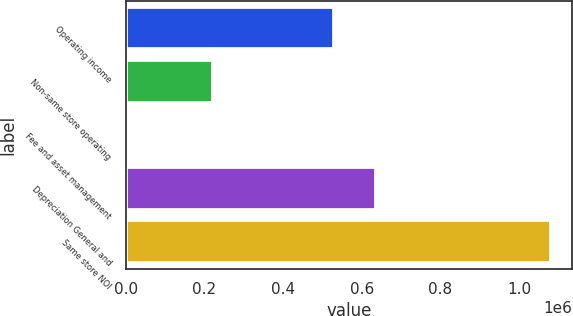<chart> <loc_0><loc_0><loc_500><loc_500><bar_chart><fcel>Operating income<fcel>Non-same store operating<fcel>Fee and asset management<fcel>Depreciation General and<fcel>Same store NOI<nl><fcel>529390<fcel>222311<fcel>7519<fcel>636786<fcel>1.08148e+06<nl></chart> 